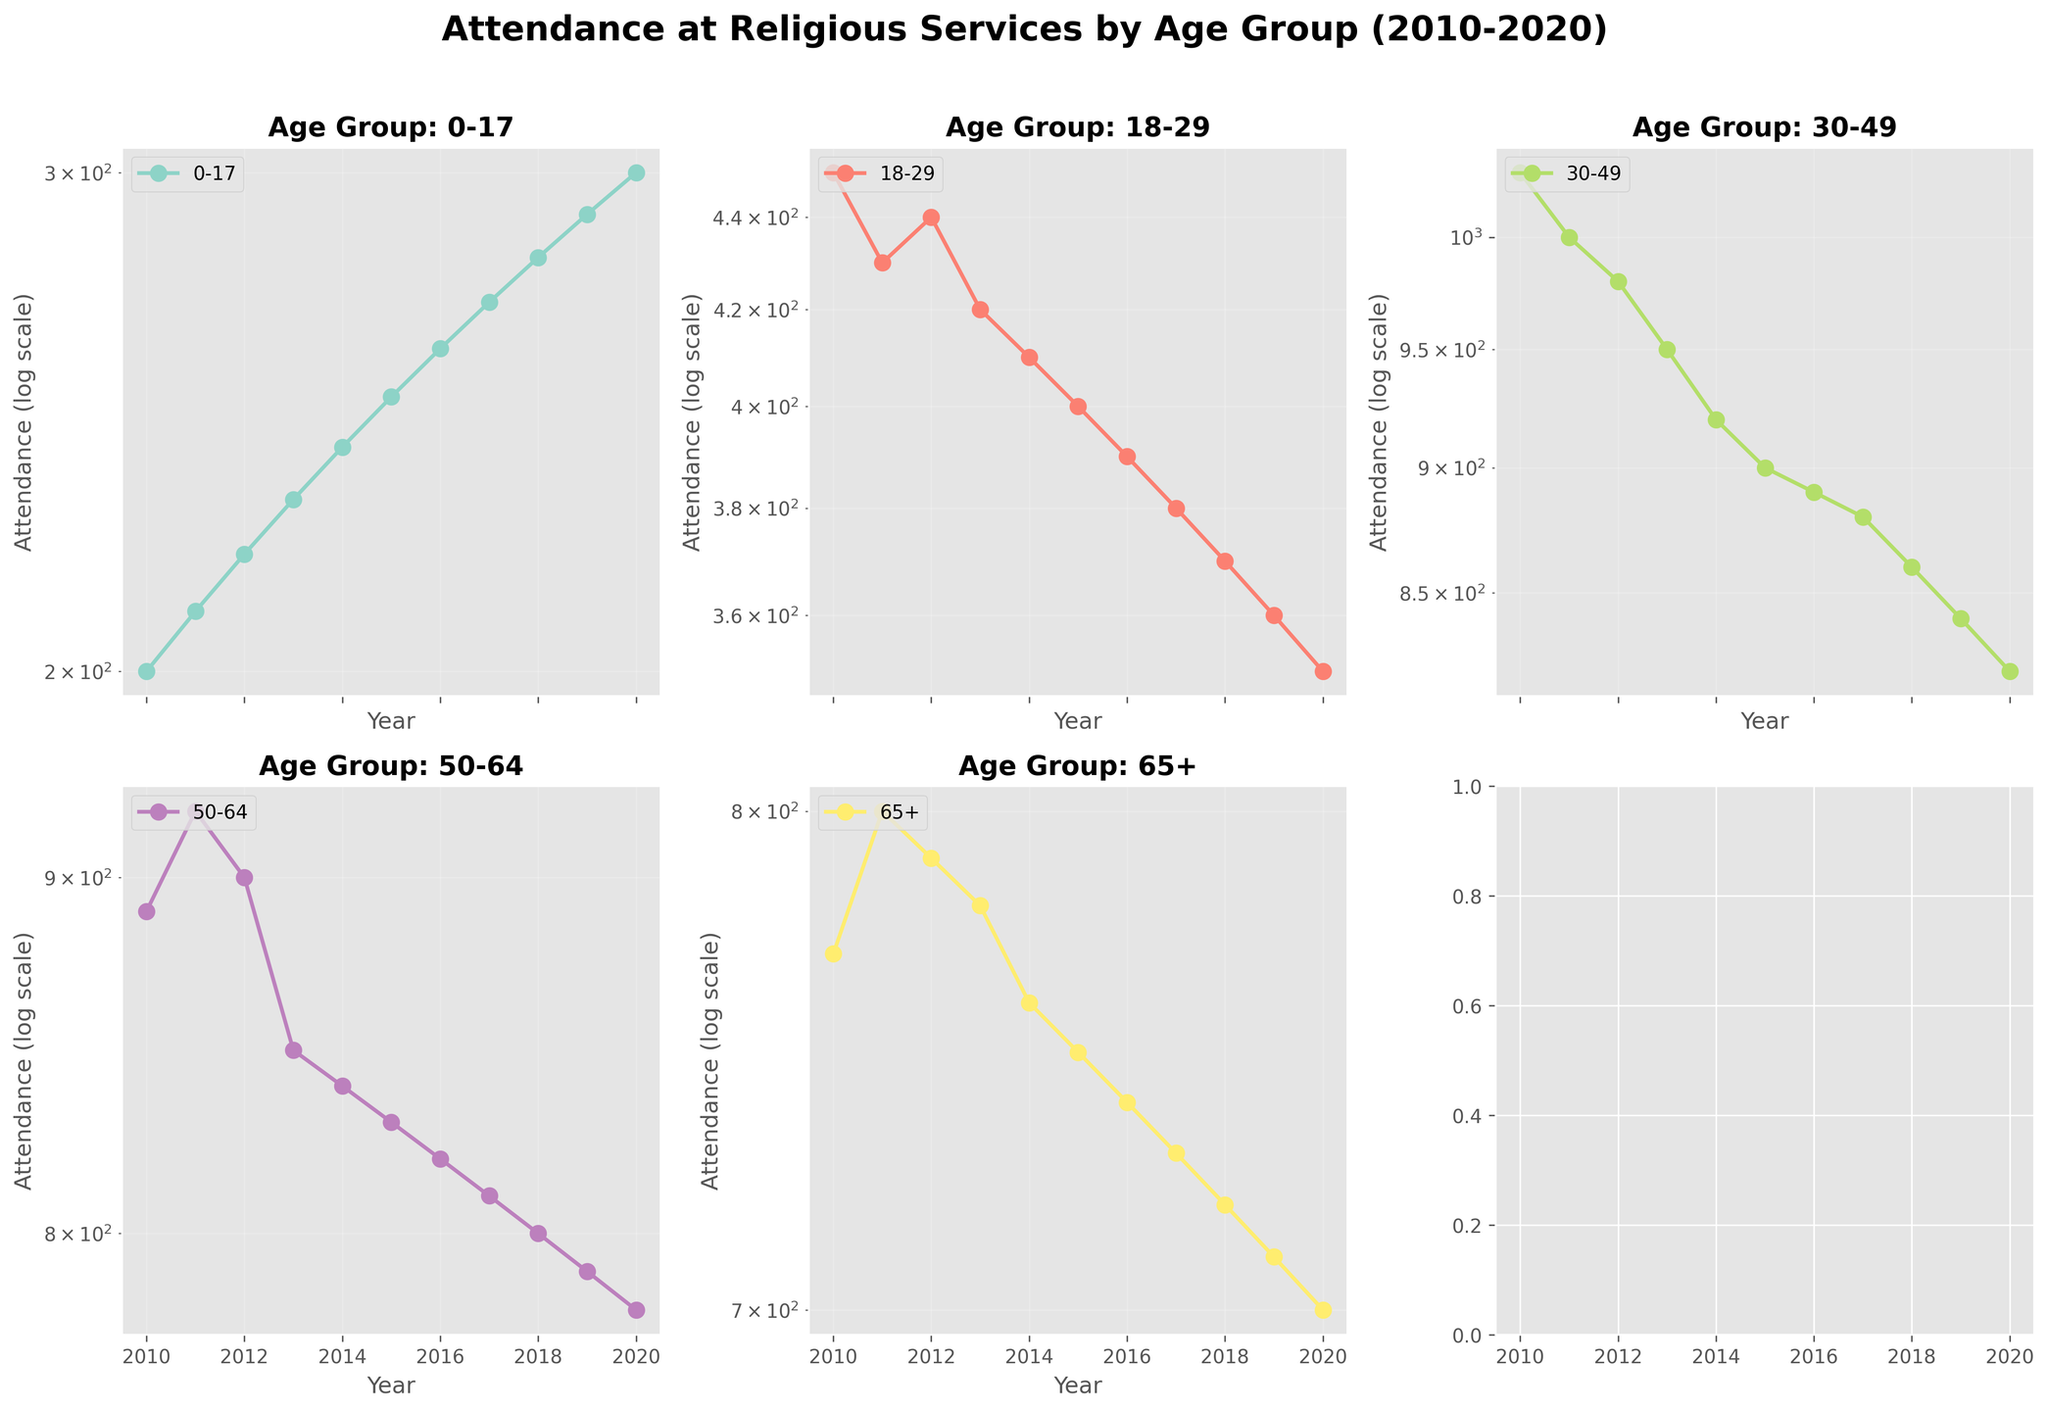Which age group has the highest attendance in 2010? Looking at the plot for the year 2010, the age group 30-49 has the highest attendance with a log-scaled value significantly higher than other groups.
Answer: 30-49 How does attendance for the age group 18-29 change from 2010 to 2020? The 18-29 age group's attendance decreases over the decade. It starts around 450 in 2010 and drops to around 350 by 2020 in the log-scaled plot.
Answer: Decreases Which age group had a steady trend in attendance over the decade? The 0-17 age group shows a consistent increase in attendance each year.
Answer: 0-17 What is the comparison of attendance between the 50-64 and 65+ age groups in 2015? In 2015, the attendance for the 50-64 age group is slightly higher than the 65+ age group as observed by their respective log-scaled points on the plot.
Answer: 50-64 is higher What age group shows the largest decrease in attendance from 2010 to 2020? Comparing the beginning and ending values on the log-scale plot, the 18-29 age group shows the largest decrease in attendance.
Answer: 18-29 Which year had the lowest attendance for the age group 0-17? By observing the data points for the 0-17 group, the year 2010 had the lowest attendance, starting from around 200.
Answer: 2010 Did the attendance for the 30-49 age group decrease or increase after 2010? The attendance for the 30-49 age group slightly decreases after 2010, as indicated by the downwards trend on the log-scale plot.
Answer: Decrease How does the attendance trend of the 65+ age group in 2012 compare with other years? In 2012, the attendance of the 65+ age group shows a slight increase from the previous year but is relatively stable compared to other significant changes in other age groups.
Answer: Slight increase What trend can be observed in the attendance of the 50-64 group over the decade? The 50-64 group's log-scale attendance remains relatively stable from 2010 to 2020 with minor fluctuations.
Answer: Stable Is there any year where the attendance for the 18-29 age group showed an increase compared to the previous year? No increase is observed in any year over the decade; the trend consistently shows a decrease or stability year-over-year.
Answer: No 